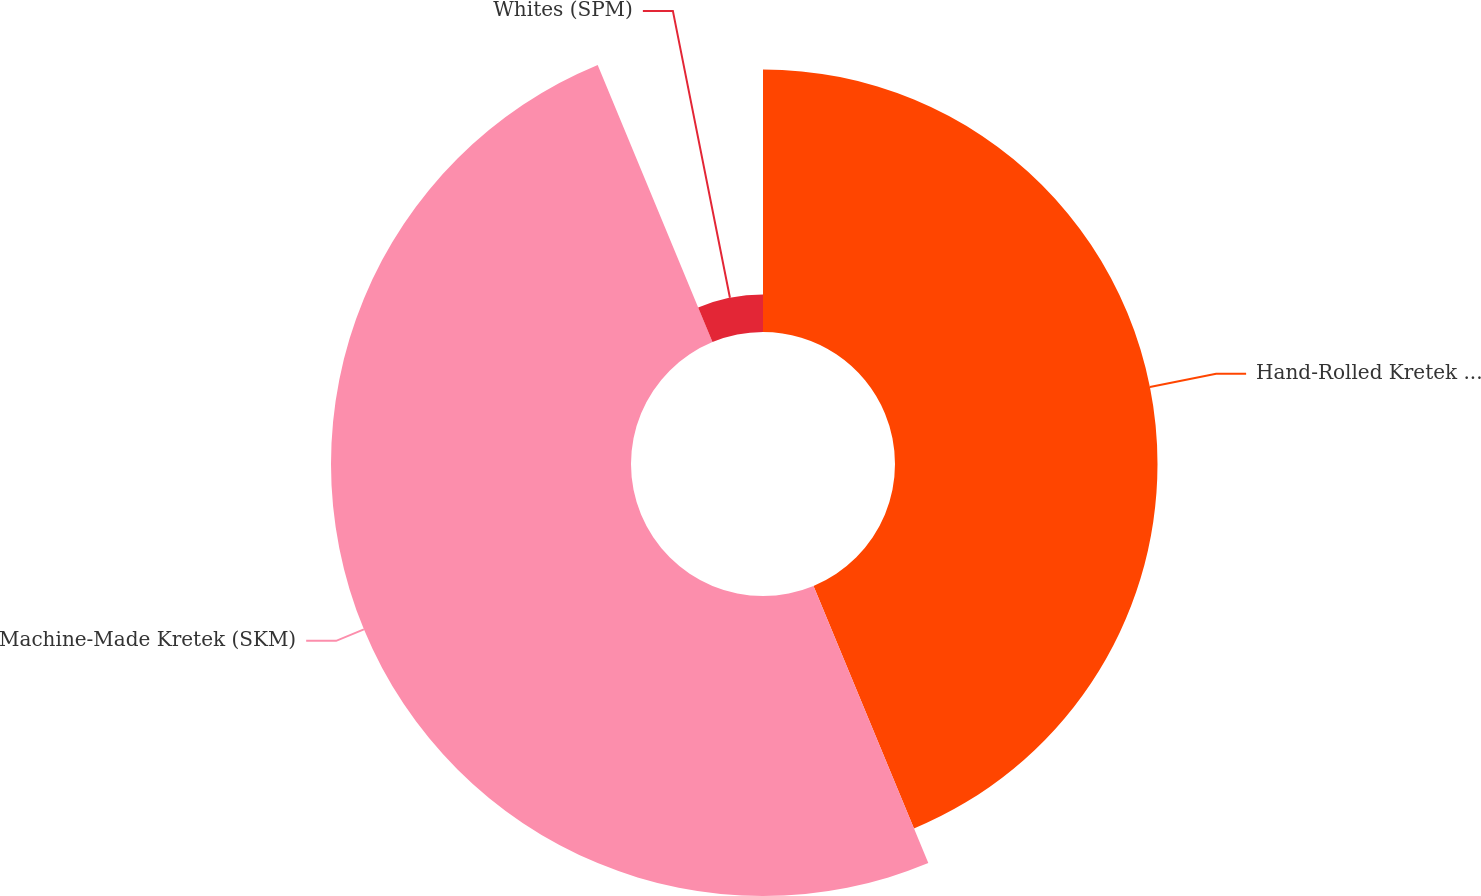Convert chart. <chart><loc_0><loc_0><loc_500><loc_500><pie_chart><fcel>Hand-Rolled Kretek (SKT)<fcel>Machine-Made Kretek (SKM)<fcel>Whites (SPM)<nl><fcel>43.75%<fcel>50.0%<fcel>6.25%<nl></chart> 